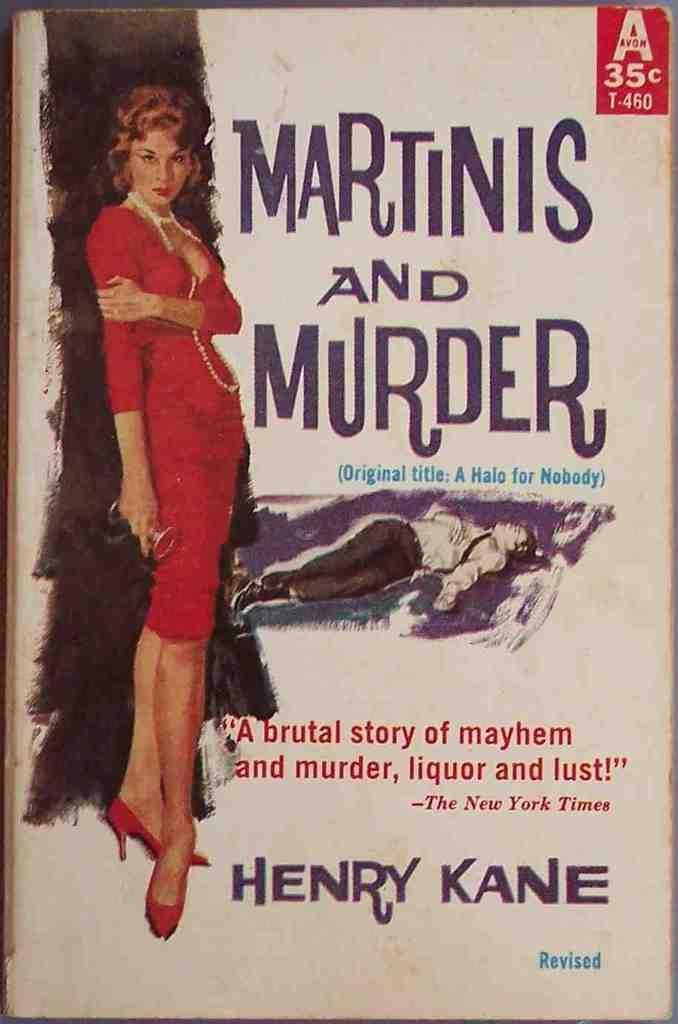How much did this issue cost?
Ensure brevity in your answer.  35 cents. What is the title of the book?
Provide a succinct answer. Martinis and murder. 